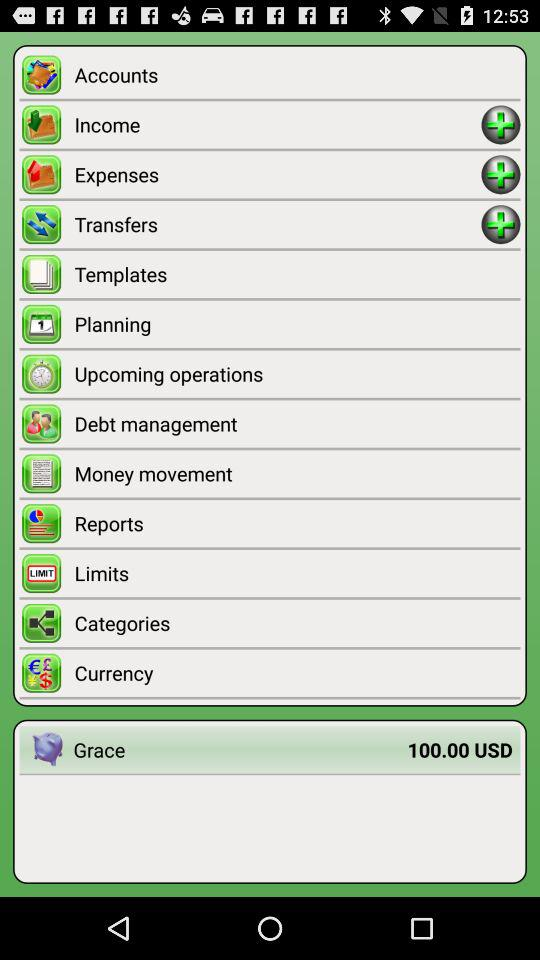What is the cost of grace given? The cost of grace is $100.00 USD. 